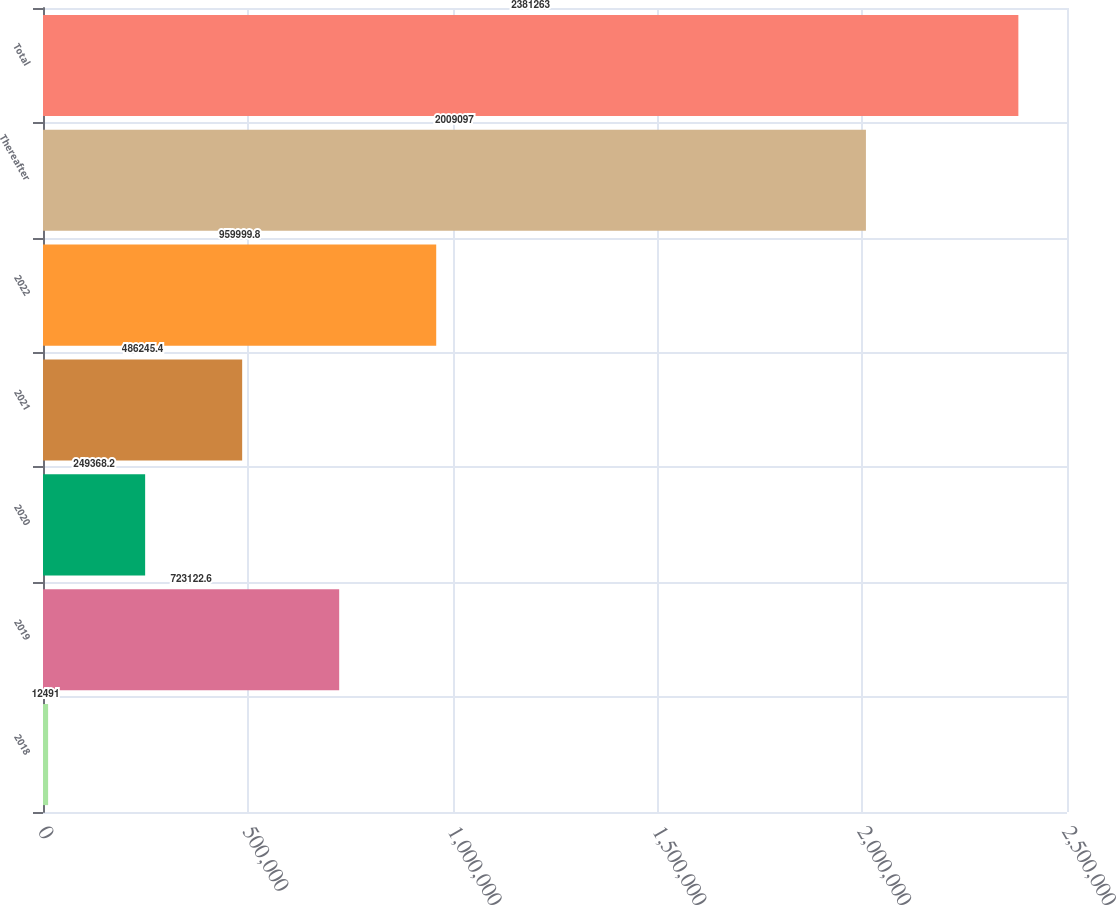Convert chart. <chart><loc_0><loc_0><loc_500><loc_500><bar_chart><fcel>2018<fcel>2019<fcel>2020<fcel>2021<fcel>2022<fcel>Thereafter<fcel>Total<nl><fcel>12491<fcel>723123<fcel>249368<fcel>486245<fcel>960000<fcel>2.0091e+06<fcel>2.38126e+06<nl></chart> 